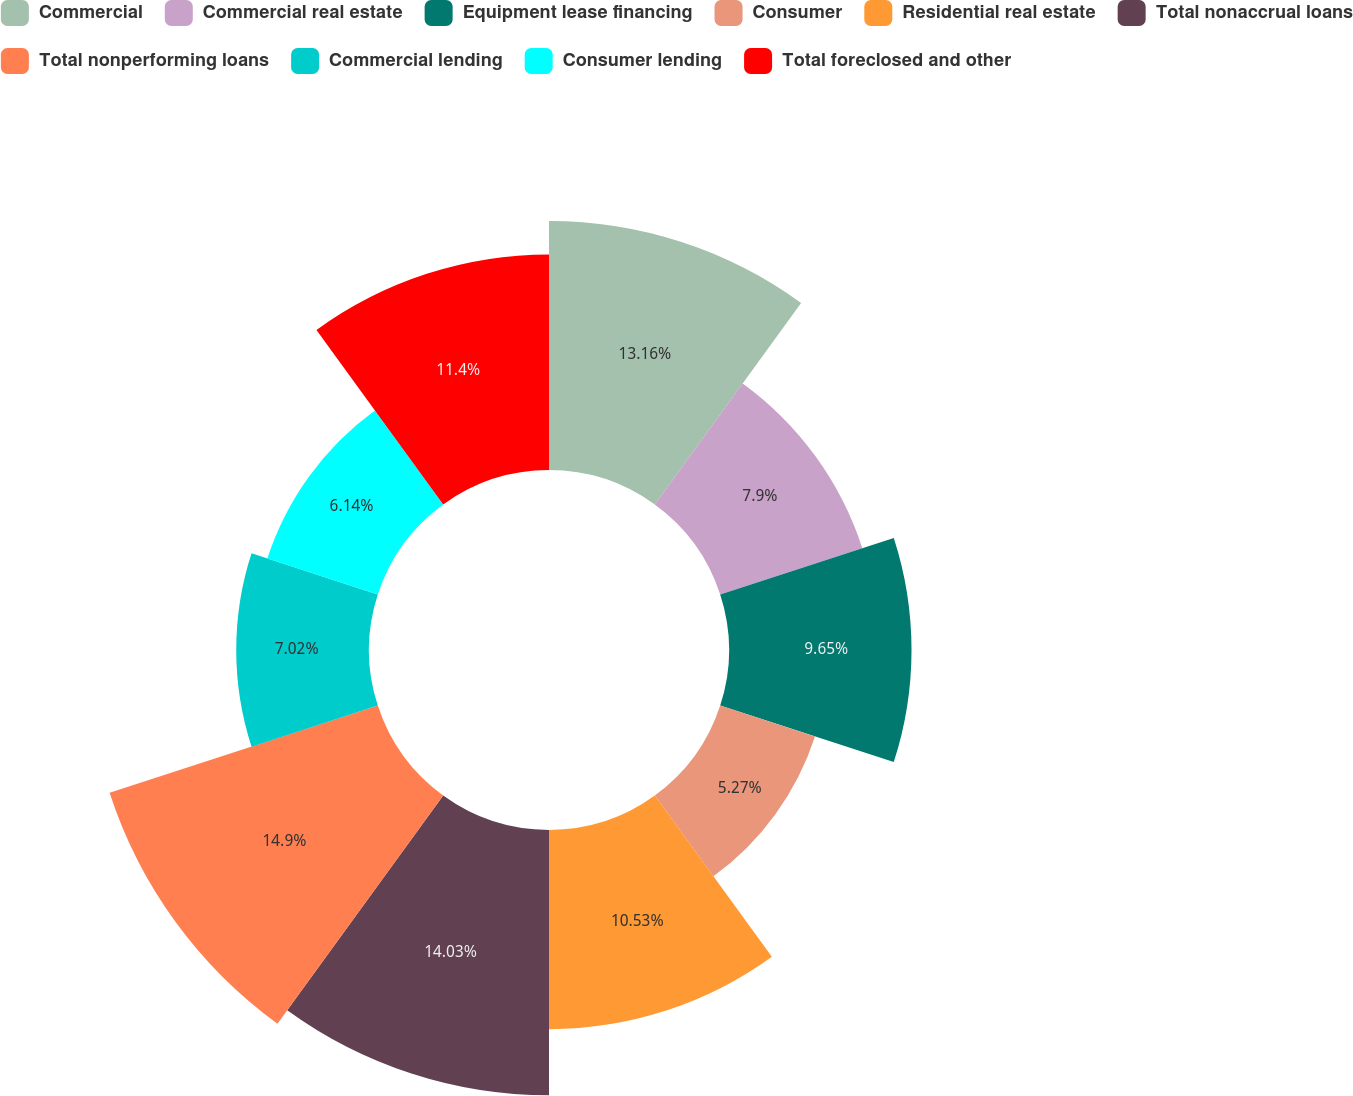<chart> <loc_0><loc_0><loc_500><loc_500><pie_chart><fcel>Commercial<fcel>Commercial real estate<fcel>Equipment lease financing<fcel>Consumer<fcel>Residential real estate<fcel>Total nonaccrual loans<fcel>Total nonperforming loans<fcel>Commercial lending<fcel>Consumer lending<fcel>Total foreclosed and other<nl><fcel>13.16%<fcel>7.9%<fcel>9.65%<fcel>5.27%<fcel>10.53%<fcel>14.03%<fcel>14.91%<fcel>7.02%<fcel>6.14%<fcel>11.4%<nl></chart> 